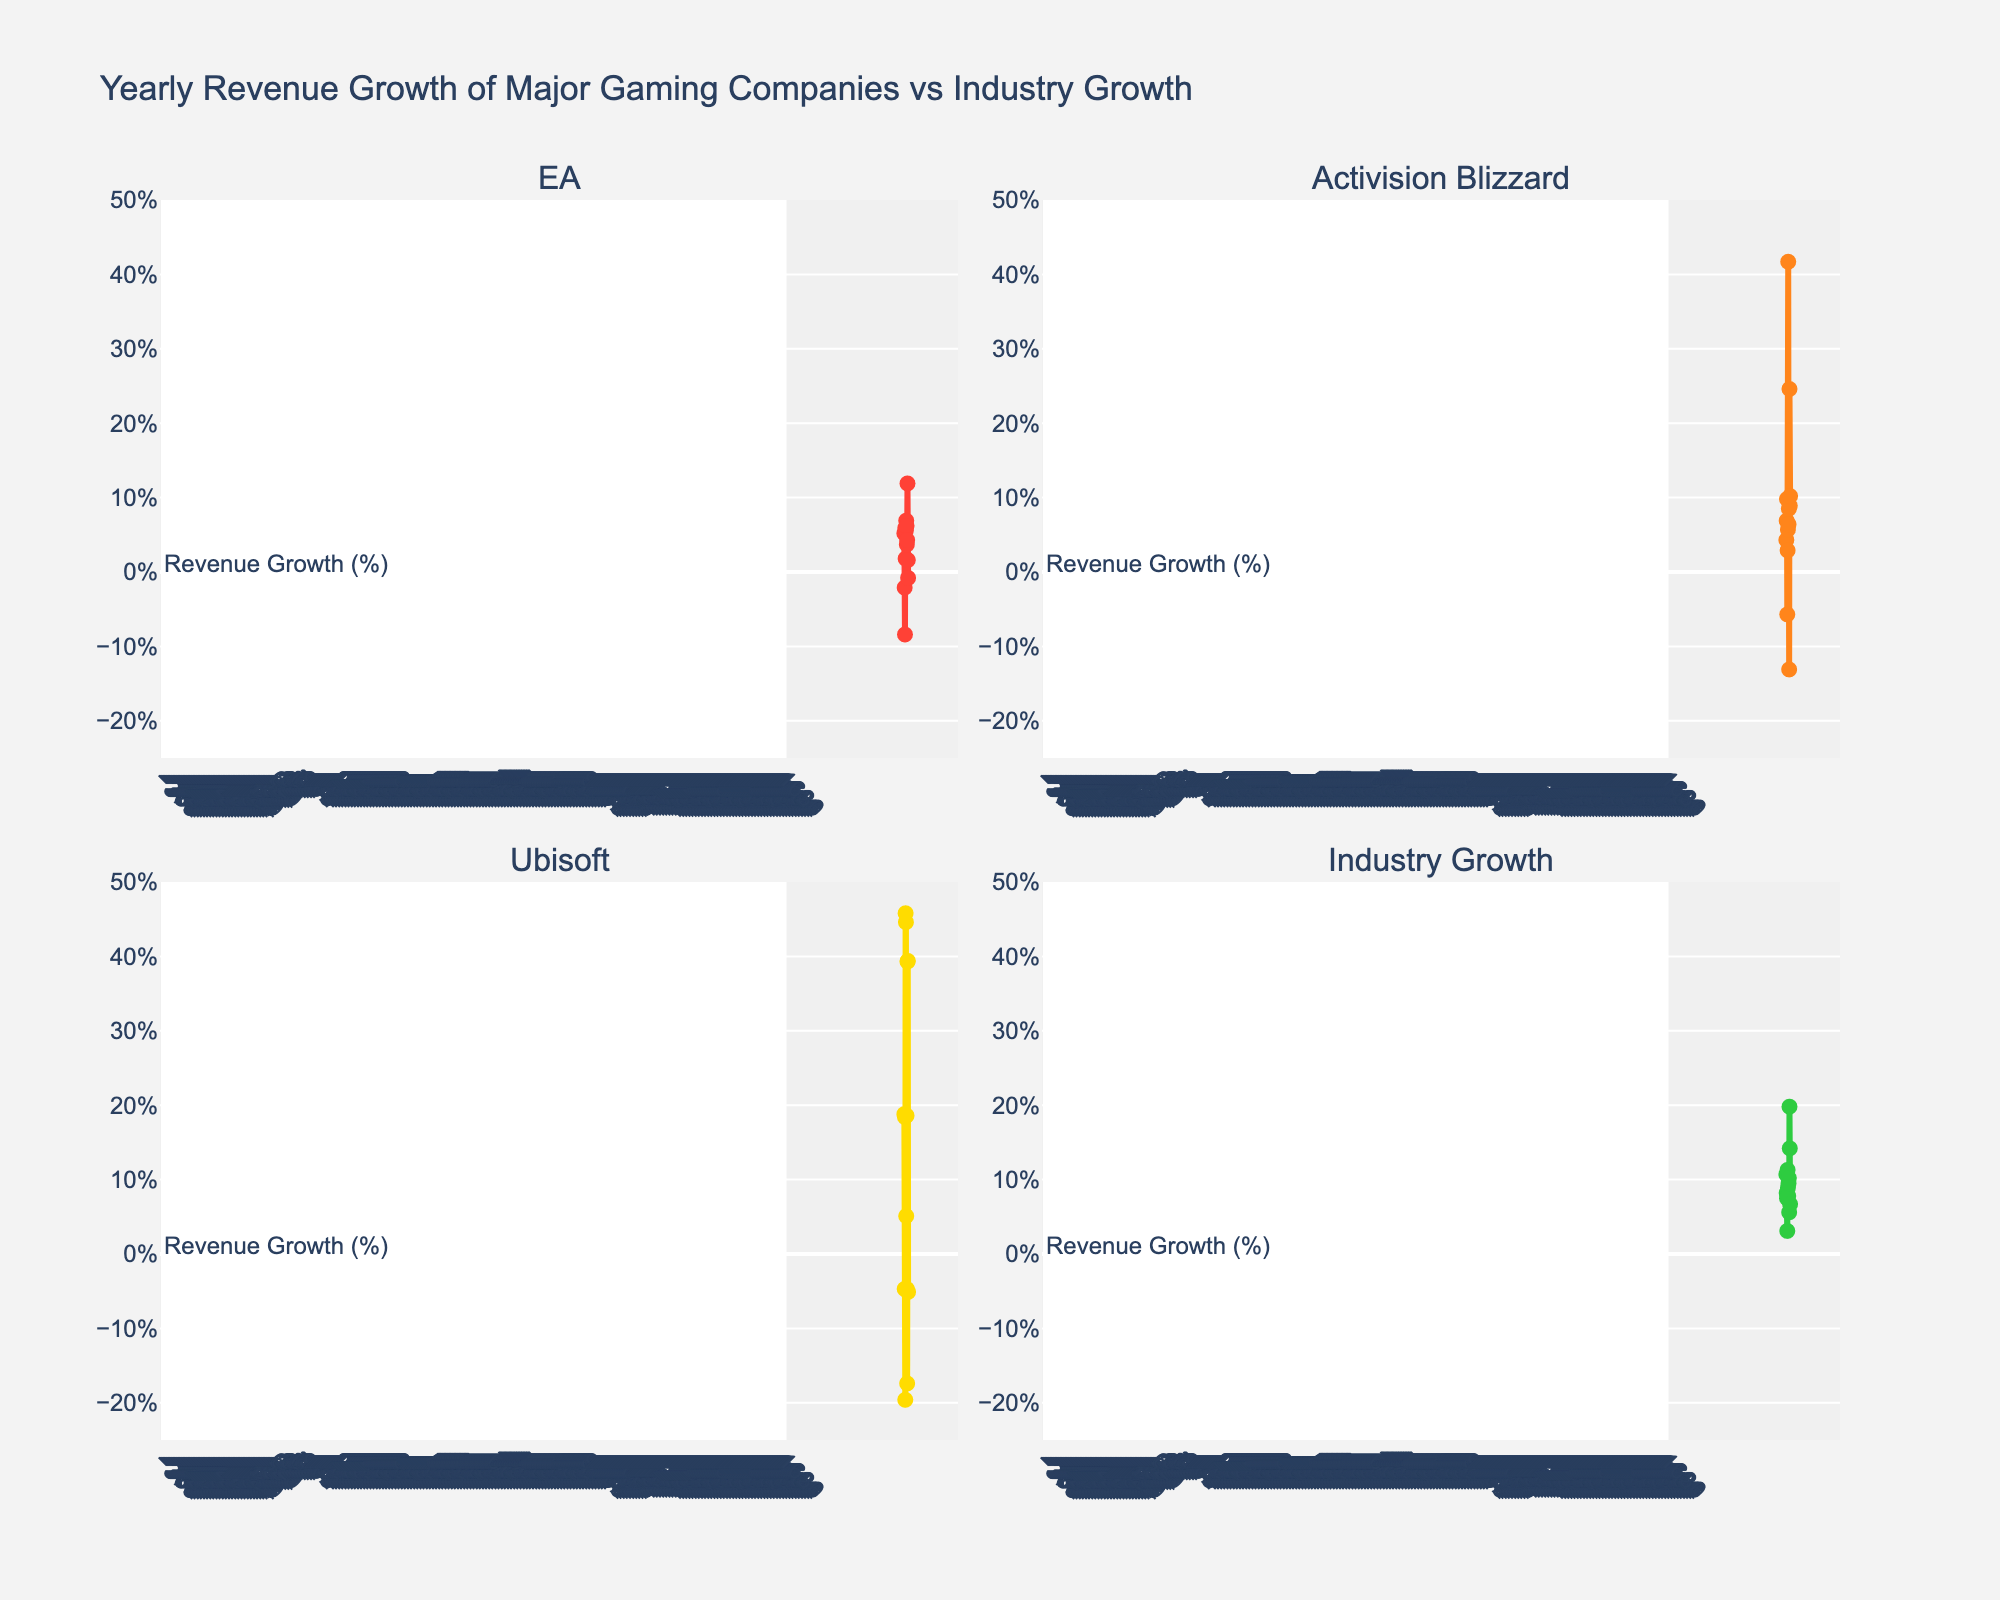what is the title of the first subplot? The subplot titles are shown at the top of each subplot. The title of the first subplot is displayed as "Investment Strategies vs. Holding Periods".
Answer: Investment Strategies vs. Holding Periods how many investment strategies are displayed on the top subplot? Count the number of distinct investment strategies on the x-axis of the top subplot. There are 10 distinct strategies displayed on the x-axis.
Answer: 10 which investment strategy has the shortest holding period? Examine the bars in the top subplot and identify the bar with the shortest length on the y-axis, which is "Day Trading" with an average holding period of 0.003 years.
Answer: Day Trading how does the aging period of Port compare to other wines? In the bottom subplot, locate the bar representing Port and compare its length to that of other wines. Port has the longest aging period of 20 years, which is significantly higher than the other wines.
Answer: Port has the longest aging period what's the difference in holding periods between the longest and shortest investment strategies? Identify the longest and shortest holding periods in the top subplot. The longest is "Buy and Hold" with 10 years, and the shortest is "Day Trading" with 0.003 years. Calculate the difference: 10 - 0.003 = 9.997 years.
Answer: 9.997 years what is the aging period of Champagne compared to Riesling? In the bottom subplot, find the bars for Champagne and Riesling and compare their lengths. Champagne has an aging period of 1.5 years, while Riesling has an aging period of 2 years.
Answer: Champagne: 1.5 years, Riesling: 2 years which investment strategy has a holding period closest to the aging period of Brunello di Montalcino? The bottom subplot shows Brunello di Montalcino has an aging period of 4 years. In the top subplot, the closest holding period is "Contrarian Investing" with 3 years.
Answer: Contrarian Investing what's the median aging period for the wines? List the aging periods: 0.25, 0.5, 1, 1.5, 2, 2, 3, 4, 5, 20 years. The median is the middle value of the sorted list, which is 2 years.
Answer: 2 years which investment strategy has a holding period twice as long as "Growth Investing"? "Growth Investing" has a holding period of 2 years, so the strategy with a period twice as long would be 4 years. The strategy closest to this value is "Brunello di Montalcino" with an aging period of 4 years.
Answer: Brunello di Montalcino what is the log-scaled y-axis used for in the top subplot? The y-axis in the top subplot is log-scaled to better visualize the large range of holding periods spanning from 0.003 to 10 years.
Answer: To better visualize large range of holding periods 